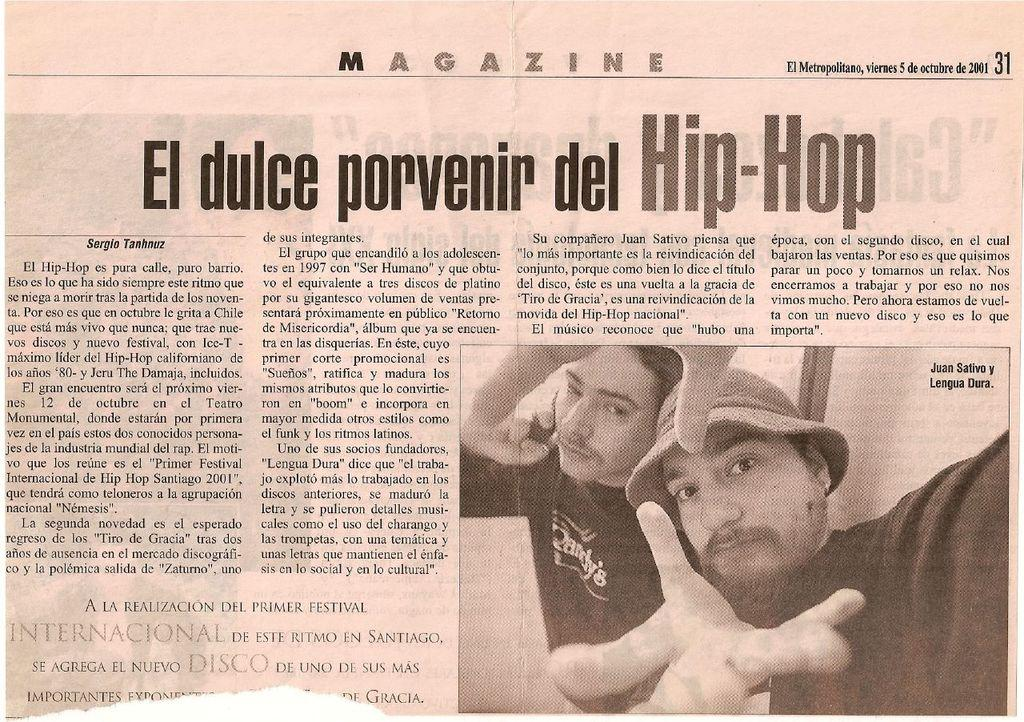What is the main subject of the image? The main subject of the image is an article. What can be found on the article? There is writing on the article. Are there any images or illustrations on the article? Yes, there is a picture of two men in the image. What type of pear is being used as a drum in the image? There is no pear or drum present in the image. Can you hear the men in the image crying? The image is a still image and does not contain any sound, so it is not possible to hear the men crying. 